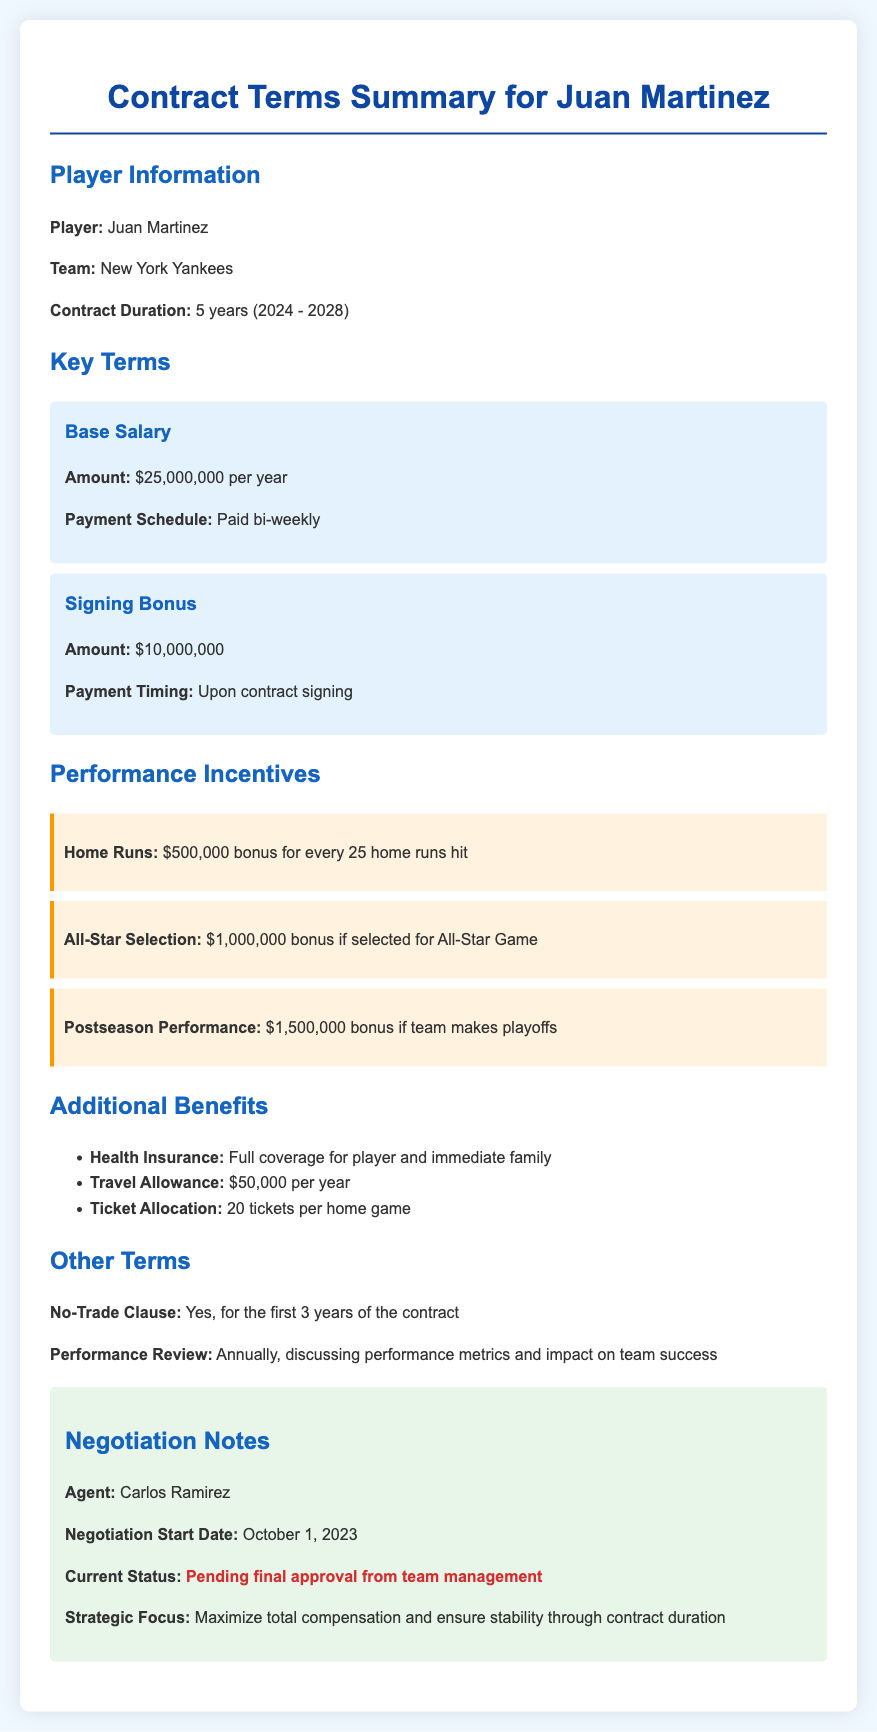What is the player's name? The player's name is mentioned in the Player Information section of the document, which states "Juan Martinez."
Answer: Juan Martinez How long is the contract duration? The contract duration is specified in the Player Information section as lasting from 2024 to 2028, totaling 5 years.
Answer: 5 years What is the amount of the signing bonus? The signing bonus amount is outlined in the Key Terms section, indicating it is $10,000,000.
Answer: $10,000,000 How much is the bonus for hitting every 25 home runs? The Performance Incentives section mentions a $500,000 bonus for every 25 home runs hit.
Answer: $500,000 Is there a no-trade clause? The Other Terms section explicitly states that there is a no-trade clause for the first 3 years of the contract.
Answer: Yes Who is the player's agent? The agent's name can be found in the Negotiation Notes section, which lists "Carlos Ramirez" as the agent.
Answer: Carlos Ramirez What is the current status of the contract negotiations? The Negotiation Notes section highlights the status as "Pending final approval from team management."
Answer: Pending final approval from team management What additional benefit includes full coverage for the player's family? The Additional Benefits section specifies that health insurance includes full coverage for the player and immediate family.
Answer: Health Insurance How many tickets are allocated per home game? The Additional Benefits section states that there are 20 tickets allocated per home game.
Answer: 20 tickets 